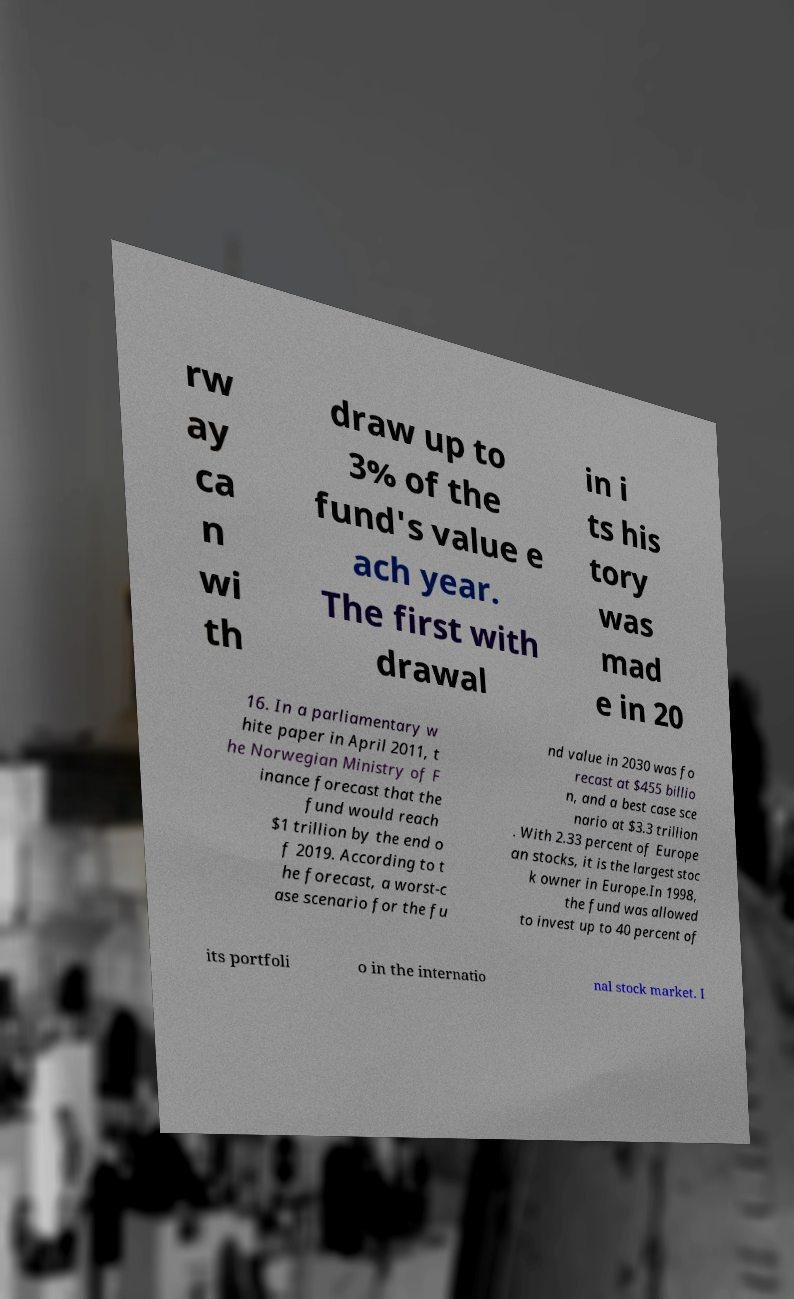What messages or text are displayed in this image? I need them in a readable, typed format. rw ay ca n wi th draw up to 3% of the fund's value e ach year. The first with drawal in i ts his tory was mad e in 20 16. In a parliamentary w hite paper in April 2011, t he Norwegian Ministry of F inance forecast that the fund would reach $1 trillion by the end o f 2019. According to t he forecast, a worst-c ase scenario for the fu nd value in 2030 was fo recast at $455 billio n, and a best case sce nario at $3.3 trillion . With 2.33 percent of Europe an stocks, it is the largest stoc k owner in Europe.In 1998, the fund was allowed to invest up to 40 percent of its portfoli o in the internatio nal stock market. I 